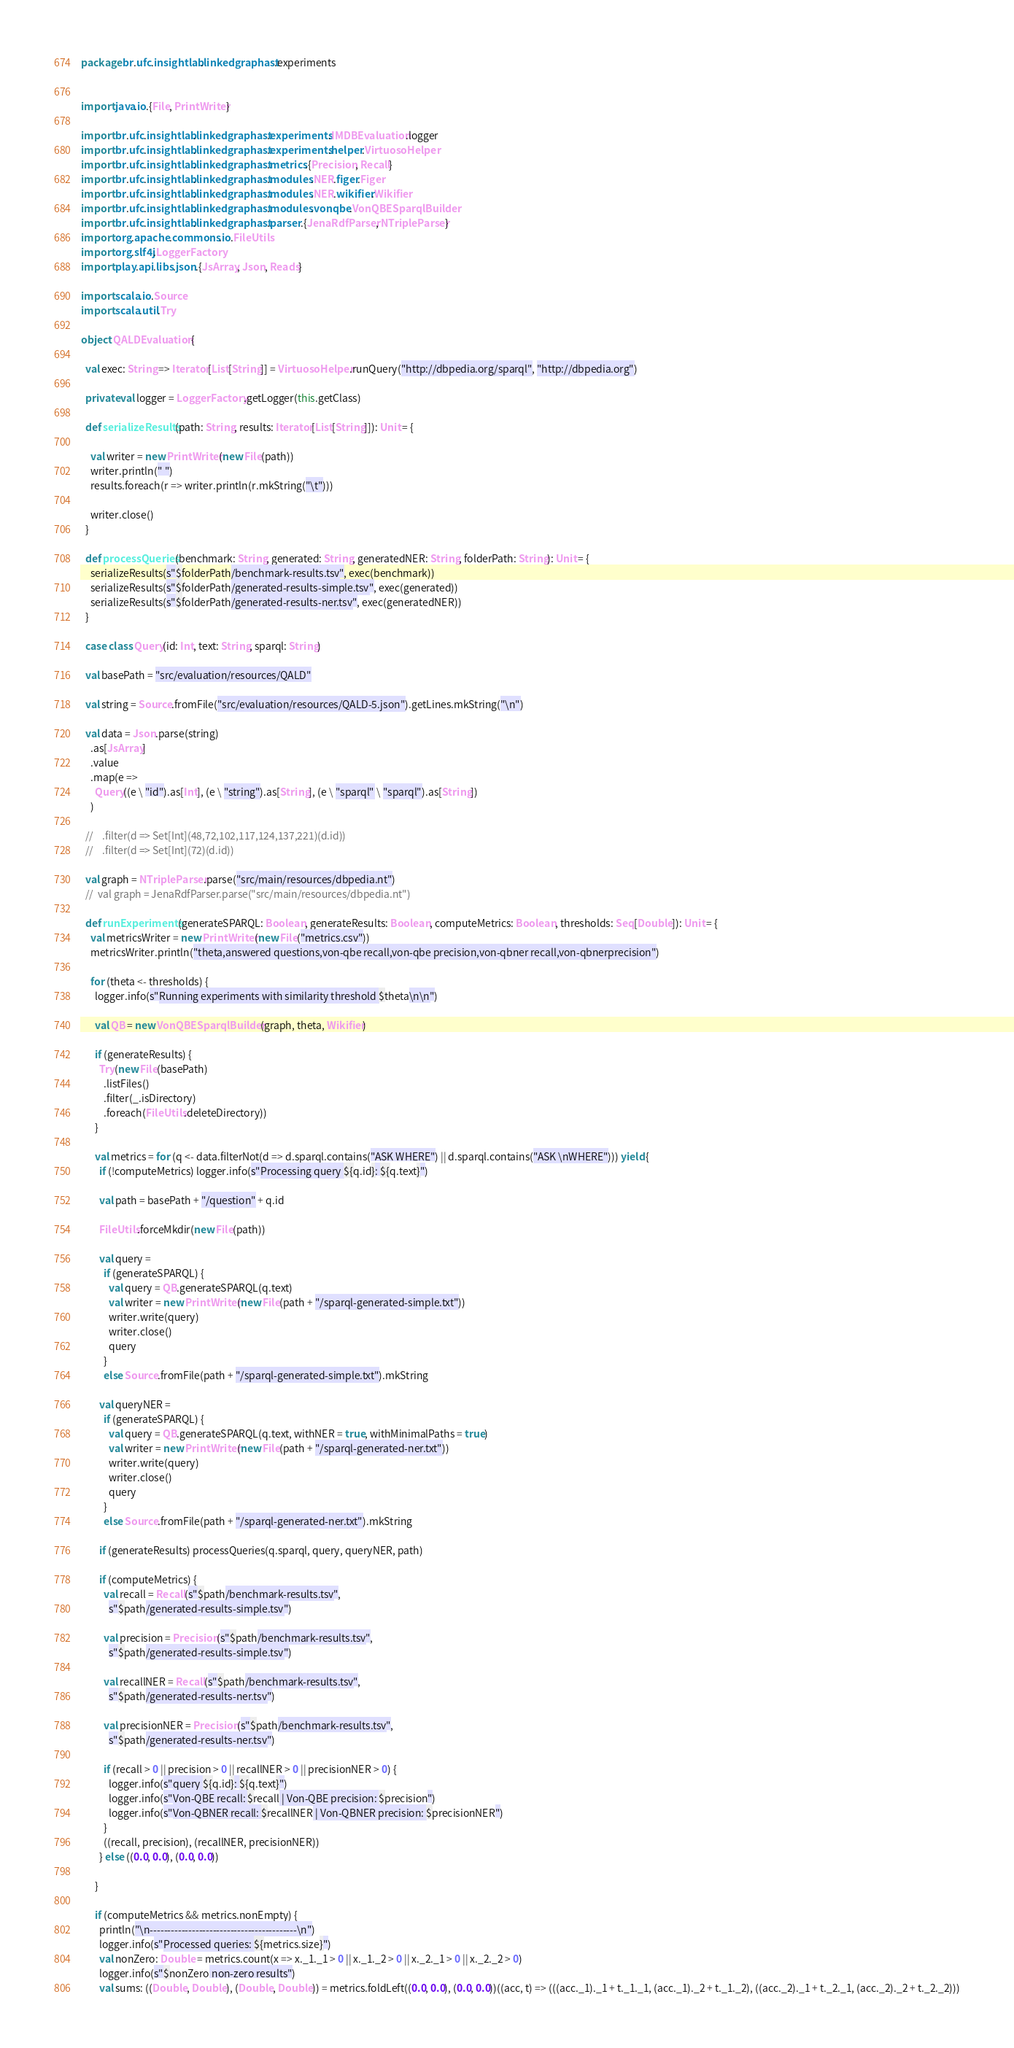<code> <loc_0><loc_0><loc_500><loc_500><_Scala_>package br.ufc.insightlab.linkedgraphast.experiments


import java.io.{File, PrintWriter}

import br.ufc.insightlab.linkedgraphast.experiments.IMDBEvaluation.logger
import br.ufc.insightlab.linkedgraphast.experiments.helper.VirtuosoHelper
import br.ufc.insightlab.linkedgraphast.metrics.{Precision, Recall}
import br.ufc.insightlab.linkedgraphast.modules.NER.figer.Figer
import br.ufc.insightlab.linkedgraphast.modules.NER.wikifier.Wikifier
import br.ufc.insightlab.linkedgraphast.modules.vonqbe.VonQBESparqlBuilder
import br.ufc.insightlab.linkedgraphast.parser.{JenaRdfParser, NTripleParser}
import org.apache.commons.io.FileUtils
import org.slf4j.LoggerFactory
import play.api.libs.json.{JsArray, Json, Reads}

import scala.io.Source
import scala.util.Try

object QALDEvaluation {

  val exec: String => Iterator[List[String]] = VirtuosoHelper.runQuery("http://dbpedia.org/sparql", "http://dbpedia.org")

  private val logger = LoggerFactory.getLogger(this.getClass)

  def serializeResults(path: String, results: Iterator[List[String]]): Unit = {

    val writer = new PrintWriter(new File(path))
    writer.println(" ")
    results.foreach(r => writer.println(r.mkString("\t")))

    writer.close()
  }

  def processQueries(benchmark: String, generated: String, generatedNER: String, folderPath: String): Unit = {
    serializeResults(s"$folderPath/benchmark-results.tsv", exec(benchmark))
    serializeResults(s"$folderPath/generated-results-simple.tsv", exec(generated))
    serializeResults(s"$folderPath/generated-results-ner.tsv", exec(generatedNER))
  }

  case class Query(id: Int, text: String, sparql: String)

  val basePath = "src/evaluation/resources/QALD"

  val string = Source.fromFile("src/evaluation/resources/QALD-5.json").getLines.mkString("\n")

  val data = Json.parse(string)
    .as[JsArray]
    .value
    .map(e =>
      Query((e \ "id").as[Int], (e \ "string").as[String], (e \ "sparql" \ "sparql").as[String])
    )

  //    .filter(d => Set[Int](48,72,102,117,124,137,221)(d.id))
  //    .filter(d => Set[Int](72)(d.id))

  val graph = NTripleParser.parse("src/main/resources/dbpedia.nt")
  //  val graph = JenaRdfParser.parse("src/main/resources/dbpedia.nt")

  def runExperiments(generateSPARQL: Boolean, generateResults: Boolean, computeMetrics: Boolean, thresholds: Seq[Double]): Unit = {
    val metricsWriter = new PrintWriter(new File("metrics.csv"))
    metricsWriter.println("theta,answered questions,von-qbe recall,von-qbe precision,von-qbner recall,von-qbnerprecision")

    for (theta <- thresholds) {
      logger.info(s"Running experiments with similarity threshold $theta\n\n")

      val QB = new VonQBESparqlBuilder(graph, theta, Wikifier)

      if (generateResults) {
        Try(new File(basePath)
          .listFiles()
          .filter(_.isDirectory)
          .foreach(FileUtils.deleteDirectory))
      }

      val metrics = for (q <- data.filterNot(d => d.sparql.contains("ASK WHERE") || d.sparql.contains("ASK \nWHERE"))) yield {
        if (!computeMetrics) logger.info(s"Processing query ${q.id}: ${q.text}")

        val path = basePath + "/question" + q.id

        FileUtils.forceMkdir(new File(path))

        val query =
          if (generateSPARQL) {
            val query = QB.generateSPARQL(q.text)
            val writer = new PrintWriter(new File(path + "/sparql-generated-simple.txt"))
            writer.write(query)
            writer.close()
            query
          }
          else Source.fromFile(path + "/sparql-generated-simple.txt").mkString

        val queryNER =
          if (generateSPARQL) {
            val query = QB.generateSPARQL(q.text, withNER = true, withMinimalPaths = true)
            val writer = new PrintWriter(new File(path + "/sparql-generated-ner.txt"))
            writer.write(query)
            writer.close()
            query
          }
          else Source.fromFile(path + "/sparql-generated-ner.txt").mkString

        if (generateResults) processQueries(q.sparql, query, queryNER, path)

        if (computeMetrics) {
          val recall = Recall(s"$path/benchmark-results.tsv",
            s"$path/generated-results-simple.tsv")

          val precision = Precision(s"$path/benchmark-results.tsv",
            s"$path/generated-results-simple.tsv")

          val recallNER = Recall(s"$path/benchmark-results.tsv",
            s"$path/generated-results-ner.tsv")

          val precisionNER = Precision(s"$path/benchmark-results.tsv",
            s"$path/generated-results-ner.tsv")

          if (recall > 0 || precision > 0 || recallNER > 0 || precisionNER > 0) {
            logger.info(s"query ${q.id}: ${q.text}")
            logger.info(s"Von-QBE recall: $recall | Von-QBE precision: $precision")
            logger.info(s"Von-QBNER recall: $recallNER | Von-QBNER precision: $precisionNER")
          }
          ((recall, precision), (recallNER, precisionNER))
        } else ((0.0, 0.0), (0.0, 0.0))

      }

      if (computeMetrics && metrics.nonEmpty) {
        println("\n------------------------------------------\n")
        logger.info(s"Processed queries: ${metrics.size}")
        val nonZero: Double = metrics.count(x => x._1._1 > 0 || x._1._2 > 0 || x._2._1 > 0 || x._2._2 > 0)
        logger.info(s"$nonZero non-zero results")
        val sums: ((Double, Double), (Double, Double)) = metrics.foldLeft((0.0, 0.0), (0.0, 0.0))((acc, t) => (((acc._1)._1 + t._1._1, (acc._1)._2 + t._1._2), ((acc._2)._1 + t._2._1, (acc._2)._2 + t._2._2)))
</code> 